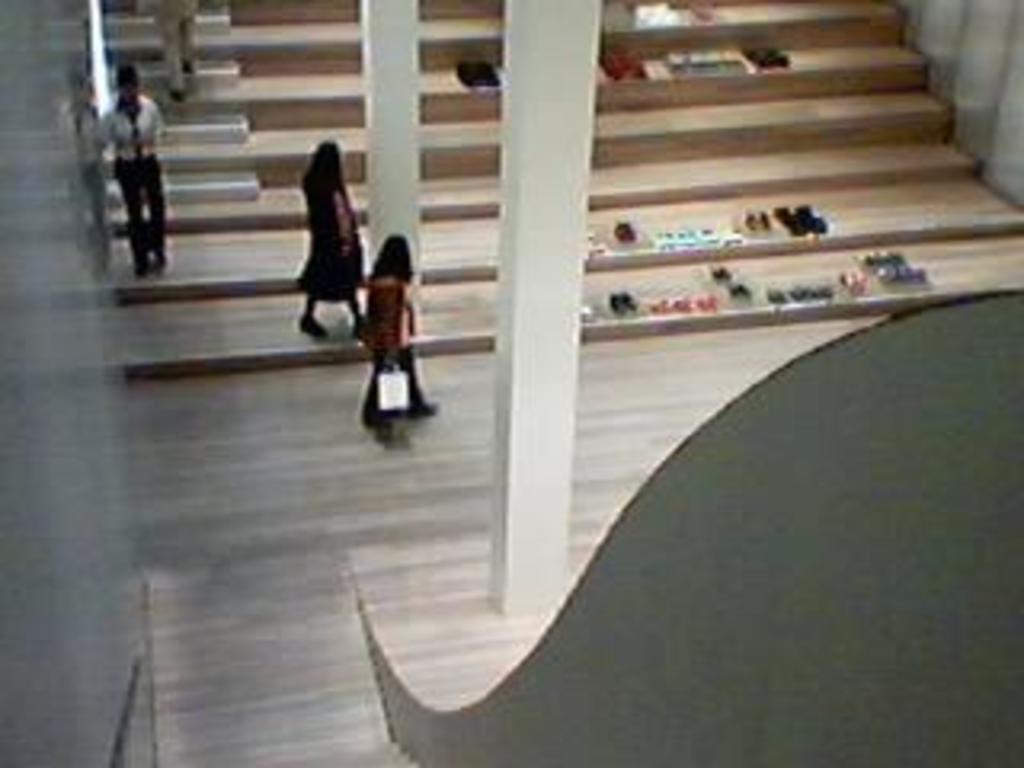In one or two sentences, can you explain what this image depicts? This picture is clicked inside. On the right corner there is an object. In the center we can see the group of people seems to be walking and we can see the two pillars and there are some objects placed on the stairs. 